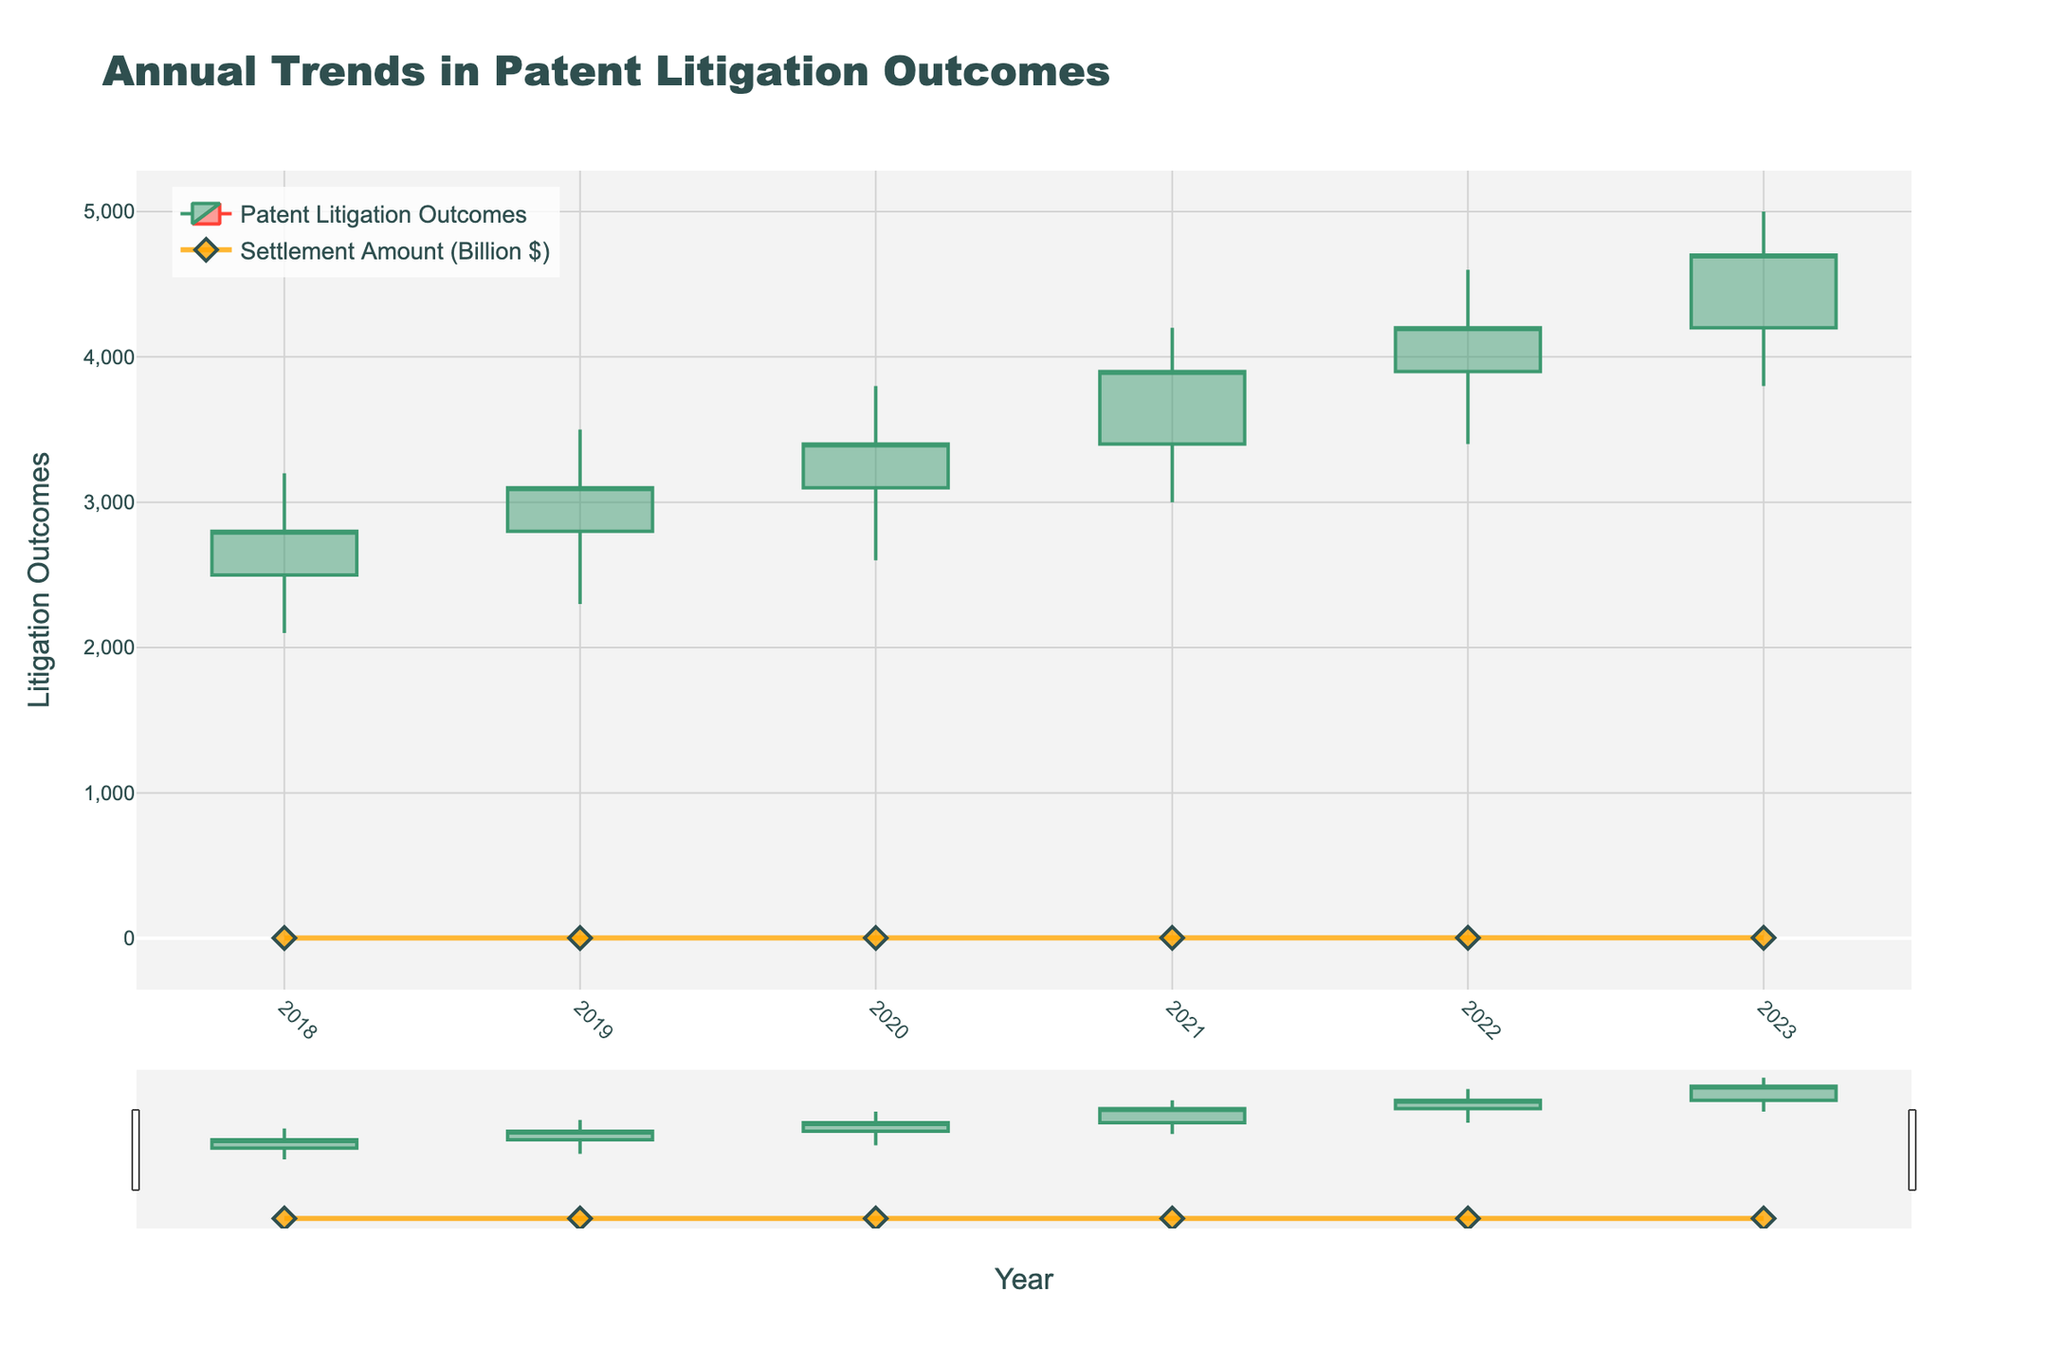What's the title of the chart? The title of the chart is usually displayed prominently at the top of the figure. Here, it reads "Annual Trends in Patent Litigation Outcomes," as indicated in the code.
Answer: Annual Trends in Patent Litigation Outcomes How many years are covered in this chart? Count the number of unique year labels shown on the x-axis. The data spans from 2018 to 2023, making a total of 6 years.
Answer: 6 Which year had the highest "High" value in patent litigation outcomes? Look at the highest points reached by the candlesticks for each year. The "High" value for 2023 is the tallest, showing 5000.
Answer: 2023 What is the settlement amount in billion dollars for 2022? Find the marker on the additional line corresponding to the year 2022 on the x-axis and look at its value on the right y-axis, which represents the settlement amount in billion dollars at 2.8.
Answer: 2.8 billion dollars Between which two consecutive years did the "Close" value increase the most? Compare the "Close" value year-by-year and find the largest increase. From 2021 to 2022, the Close increased from 3900 to 4200.
Answer: From 2021 to 2022 What is the average "Settlement Amount" from 2018 to 2023? Sum the settlement amounts from all years and divide by the number of years: (1.5 + 1.75 + 2.1 + 2.4 + 2.8 + 3.2) / 6 = 2.295 billion dollars.
Answer: 2.295 billion dollars In which year did the "Close" value surpass the "High" value of the previous year? Compare the close values against the high values of previous years. In 2019, the close value (3100) surpasses the high of 2018 (3200), and this pattern holds for subsequent years.
Answer: 2019 How did the "Open" value change from 2020 to 2021? Look at the "Open" values for 2020 (3100) and 2021 (3400) and calculate the difference: 3400 - 3100 = 300.
Answer: Increased by 300 What was the "Low" value in 2020, and how does it compare to the "Low" value in 2021? Check the "Low" values for 2020 (2600) and compare it to 2021 (3000). To find the difference: 3000 - 2600 = 400.
Answer: It increased by 400 